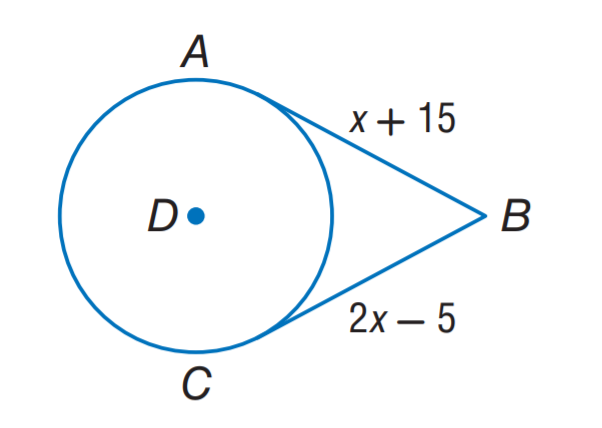Answer the mathemtical geometry problem and directly provide the correct option letter.
Question: A B and C B are tangent to \odot D. Find the value of x.
Choices: A: 10 B: 15 C: 20 D: 25 C 